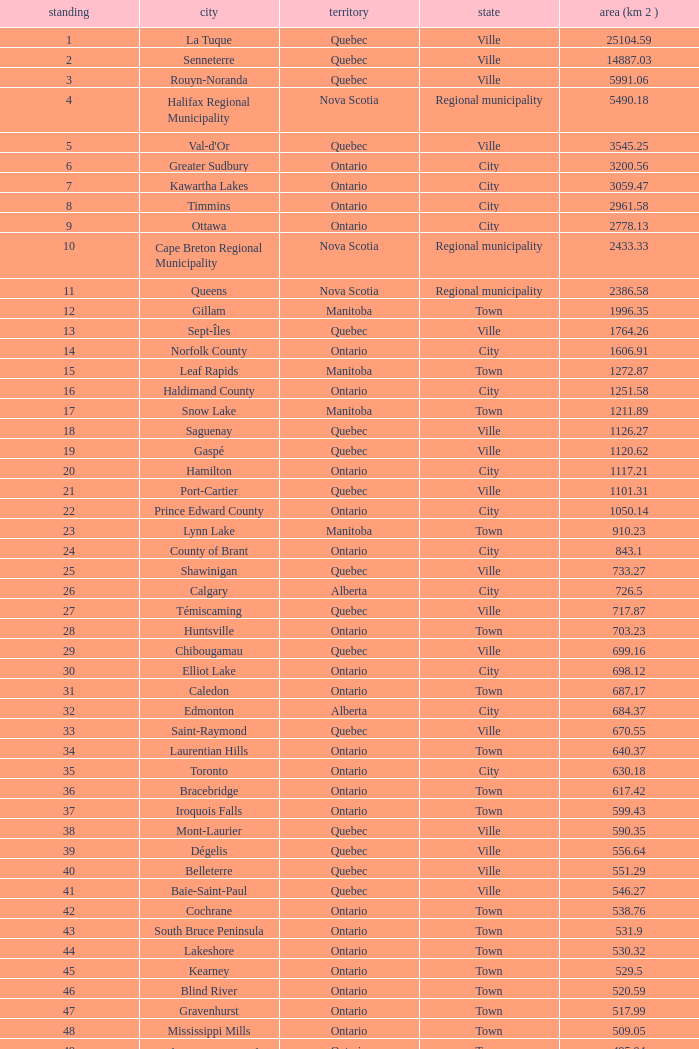01? None. 